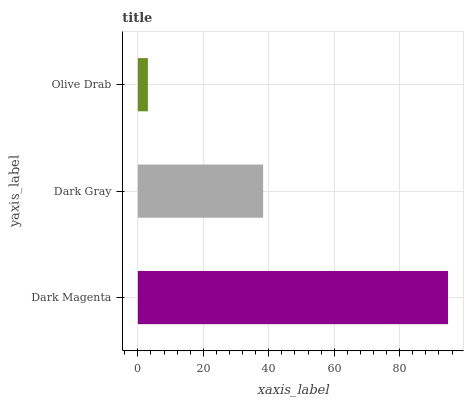Is Olive Drab the minimum?
Answer yes or no. Yes. Is Dark Magenta the maximum?
Answer yes or no. Yes. Is Dark Gray the minimum?
Answer yes or no. No. Is Dark Gray the maximum?
Answer yes or no. No. Is Dark Magenta greater than Dark Gray?
Answer yes or no. Yes. Is Dark Gray less than Dark Magenta?
Answer yes or no. Yes. Is Dark Gray greater than Dark Magenta?
Answer yes or no. No. Is Dark Magenta less than Dark Gray?
Answer yes or no. No. Is Dark Gray the high median?
Answer yes or no. Yes. Is Dark Gray the low median?
Answer yes or no. Yes. Is Olive Drab the high median?
Answer yes or no. No. Is Dark Magenta the low median?
Answer yes or no. No. 